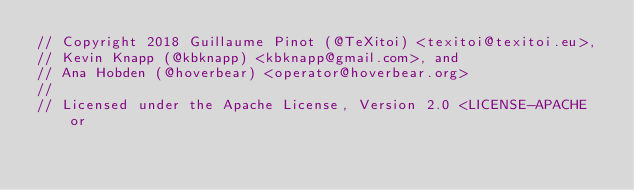Convert code to text. <code><loc_0><loc_0><loc_500><loc_500><_Rust_>// Copyright 2018 Guillaume Pinot (@TeXitoi) <texitoi@texitoi.eu>,
// Kevin Knapp (@kbknapp) <kbknapp@gmail.com>, and
// Ana Hobden (@hoverbear) <operator@hoverbear.org>
//
// Licensed under the Apache License, Version 2.0 <LICENSE-APACHE or</code> 